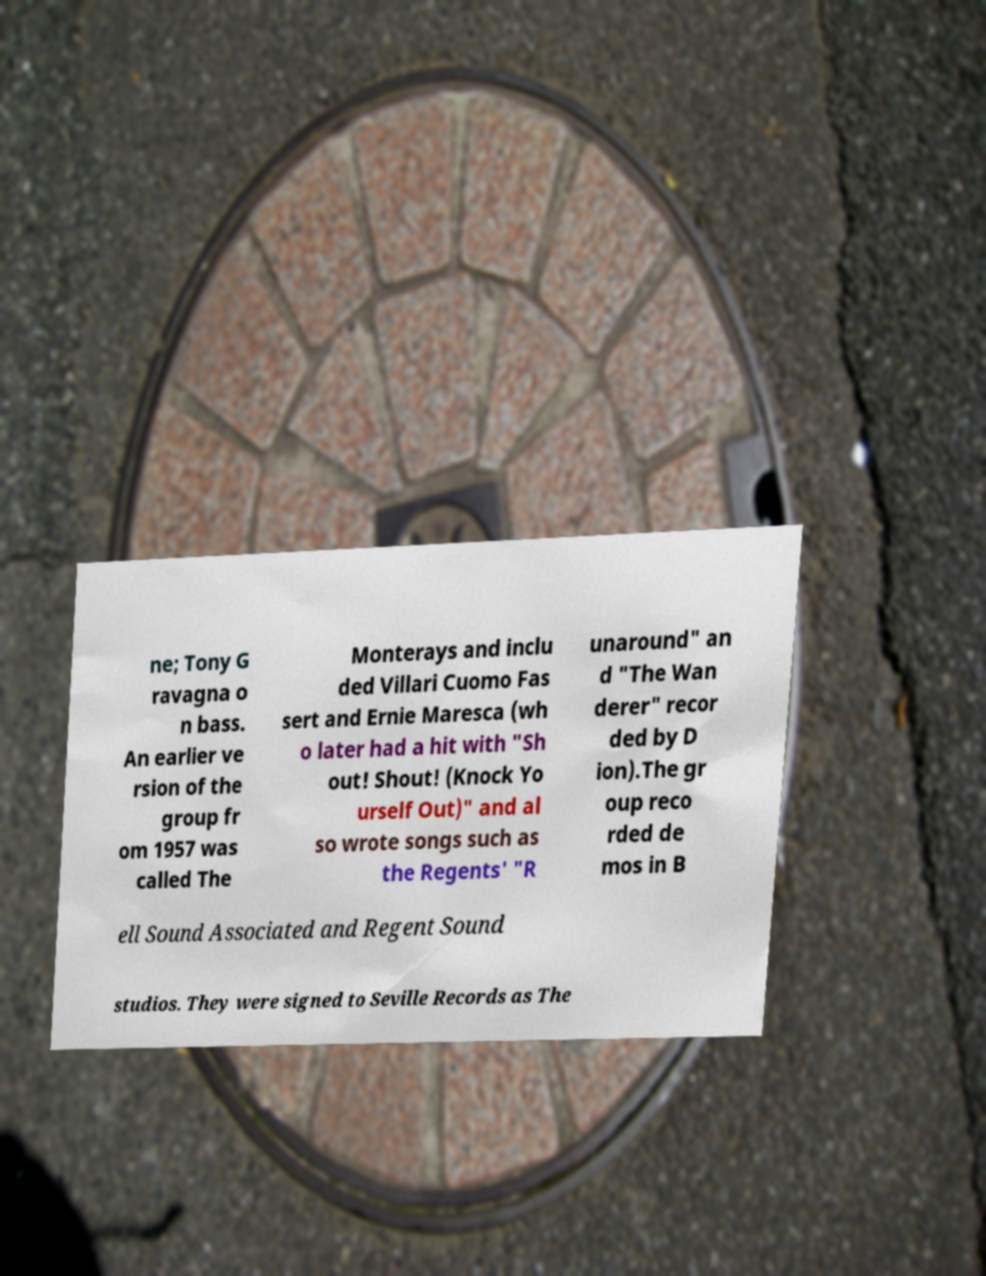I need the written content from this picture converted into text. Can you do that? ne; Tony G ravagna o n bass. An earlier ve rsion of the group fr om 1957 was called The Monterays and inclu ded Villari Cuomo Fas sert and Ernie Maresca (wh o later had a hit with "Sh out! Shout! (Knock Yo urself Out)" and al so wrote songs such as the Regents' "R unaround" an d "The Wan derer" recor ded by D ion).The gr oup reco rded de mos in B ell Sound Associated and Regent Sound studios. They were signed to Seville Records as The 